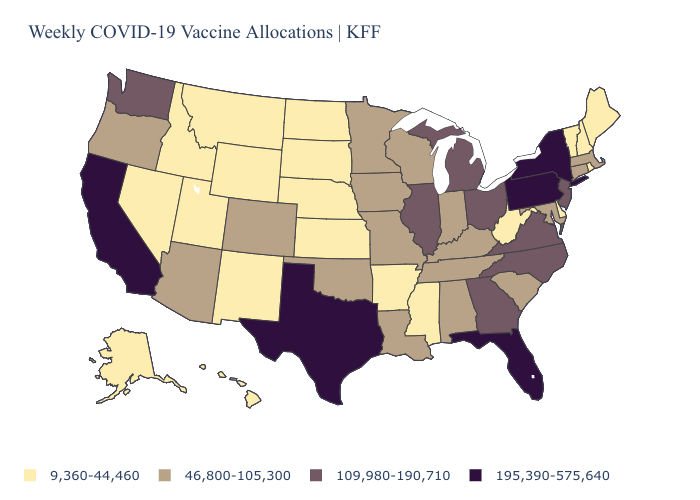What is the highest value in states that border New York?
Concise answer only. 195,390-575,640. Does Arizona have the lowest value in the West?
Answer briefly. No. Which states have the highest value in the USA?
Keep it brief. California, Florida, New York, Pennsylvania, Texas. Does Ohio have a higher value than Florida?
Be succinct. No. Which states have the highest value in the USA?
Give a very brief answer. California, Florida, New York, Pennsylvania, Texas. What is the value of Illinois?
Short answer required. 109,980-190,710. Does New Hampshire have a higher value than New Mexico?
Give a very brief answer. No. What is the value of Indiana?
Write a very short answer. 46,800-105,300. Name the states that have a value in the range 195,390-575,640?
Concise answer only. California, Florida, New York, Pennsylvania, Texas. Name the states that have a value in the range 46,800-105,300?
Be succinct. Alabama, Arizona, Colorado, Connecticut, Indiana, Iowa, Kentucky, Louisiana, Maryland, Massachusetts, Minnesota, Missouri, Oklahoma, Oregon, South Carolina, Tennessee, Wisconsin. What is the value of Wyoming?
Be succinct. 9,360-44,460. Name the states that have a value in the range 46,800-105,300?
Concise answer only. Alabama, Arizona, Colorado, Connecticut, Indiana, Iowa, Kentucky, Louisiana, Maryland, Massachusetts, Minnesota, Missouri, Oklahoma, Oregon, South Carolina, Tennessee, Wisconsin. What is the value of Nebraska?
Concise answer only. 9,360-44,460. What is the value of Maryland?
Quick response, please. 46,800-105,300. What is the lowest value in states that border North Carolina?
Answer briefly. 46,800-105,300. 